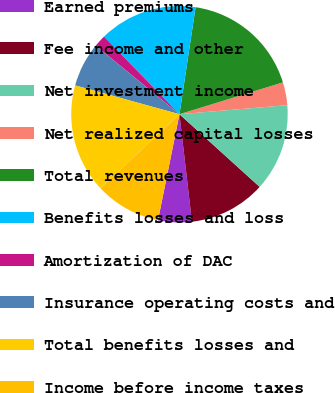<chart> <loc_0><loc_0><loc_500><loc_500><pie_chart><fcel>Earned premiums<fcel>Fee income and other<fcel>Net investment income<fcel>Net realized capital losses<fcel>Total revenues<fcel>Benefits losses and loss<fcel>Amortization of DAC<fcel>Insurance operating costs and<fcel>Total benefits losses and<fcel>Income before income taxes<nl><fcel>5.02%<fcel>11.44%<fcel>13.05%<fcel>3.42%<fcel>17.86%<fcel>14.65%<fcel>1.81%<fcel>6.63%<fcel>16.26%<fcel>9.84%<nl></chart> 